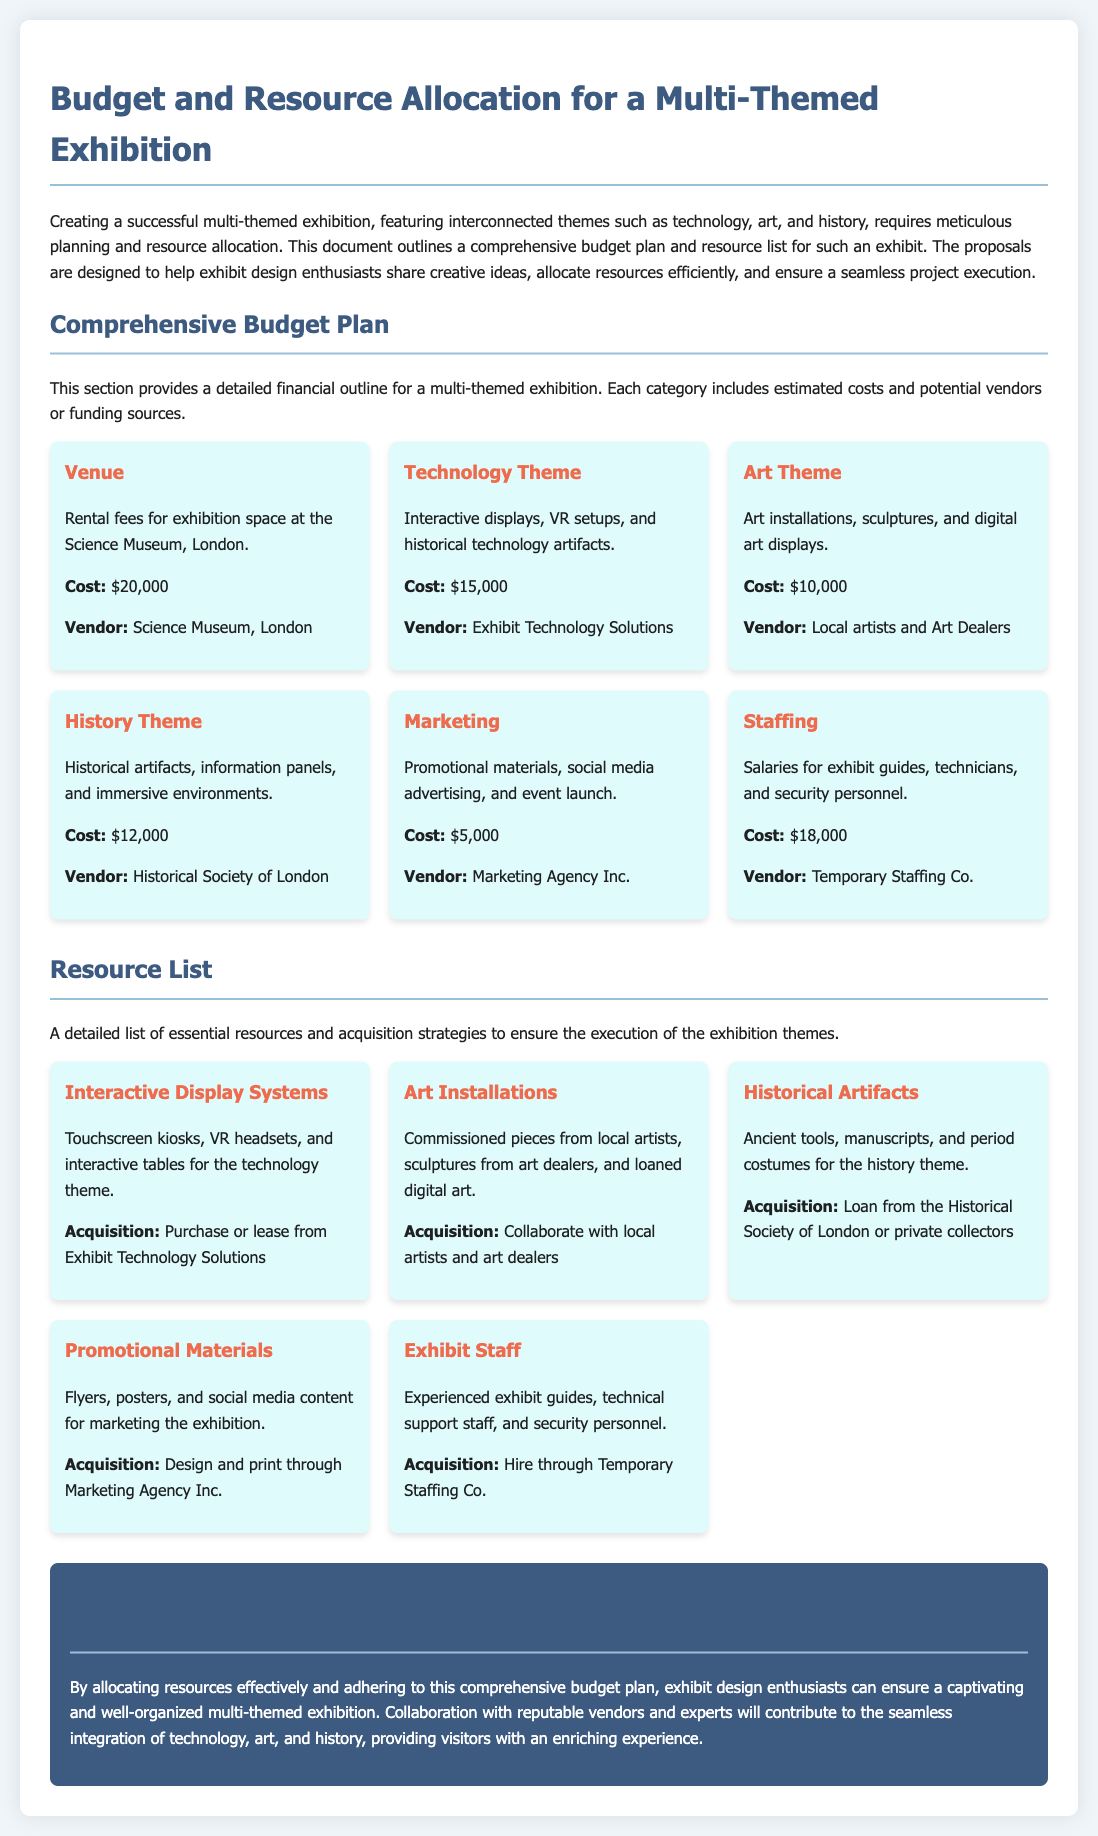What is the total cost for the Technology Theme? The cost for the Technology Theme is specified in the budget plan as $15,000.
Answer: $15,000 Which vendor is providing the Historical artifacts? The vendor for Historical artifacts is mentioned as the Historical Society of London.
Answer: Historical Society of London What is the cost allocated for Marketing? The budget plan includes a specific cost for Marketing, which is $5,000.
Answer: $5,000 What type of display systems are needed for the Technology theme? The resource list specifies the need for Touchscreen kiosks, VR headsets, and interactive tables.
Answer: Touchscreen kiosks, VR headsets, and interactive tables Which resource is acquired through collaboration with local artists? The document states that Art Installations are acquired through collaboration with local artists and art dealers.
Answer: Art Installations How much is allocated for Staffing? Staffing budget is explicitly noted as $18,000.
Answer: $18,000 Which type of personnel is included in the staffing costs? The staffing costs include exhibit guides, technicians, and security personnel.
Answer: exhibit guides, technicians, and security personnel What is the purpose of the comprehensive budget plan outlined? The comprehensive budget plan is designed to help exhibit design enthusiasts allocate resources efficiently and ensure seamless project execution.
Answer: allocate resources efficiently and ensure seamless project execution 